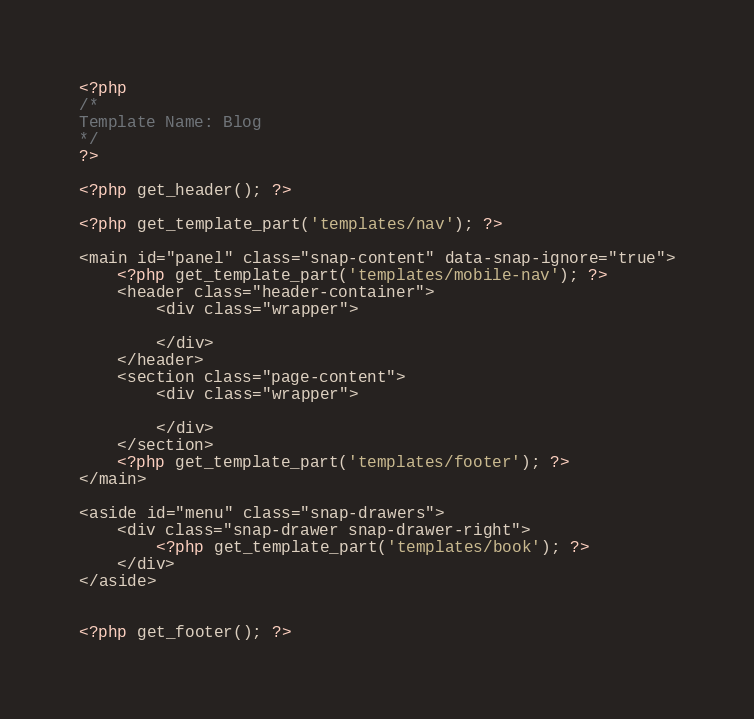Convert code to text. <code><loc_0><loc_0><loc_500><loc_500><_PHP_><?php 
/*
Template Name: Blog
*/
?>

<?php get_header(); ?>

<?php get_template_part('templates/nav'); ?>

<main id="panel" class="snap-content" data-snap-ignore="true">
	<?php get_template_part('templates/mobile-nav'); ?>
	<header class="header-container">
		<div class="wrapper">
			
		</div>
	</header>
	<section class="page-content">
		<div class="wrapper">
			
		</div>
	</section>
	<?php get_template_part('templates/footer'); ?>
</main>

<aside id="menu" class="snap-drawers">
	<div class="snap-drawer snap-drawer-right">
		<?php get_template_part('templates/book'); ?>
	</div>
</aside>


<?php get_footer(); ?>
</code> 